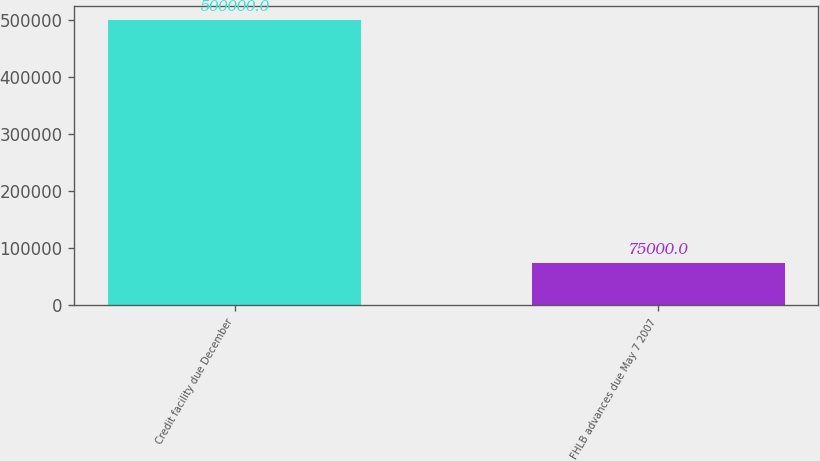Convert chart to OTSL. <chart><loc_0><loc_0><loc_500><loc_500><bar_chart><fcel>Credit facility due December<fcel>FHLB advances due May 7 2007<nl><fcel>500000<fcel>75000<nl></chart> 